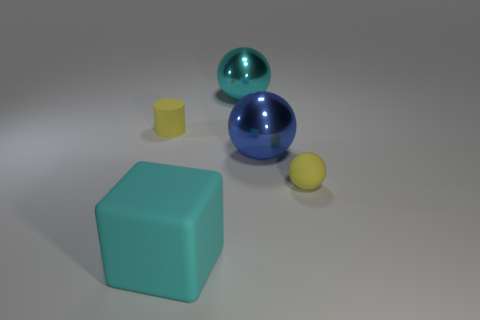What is the big blue object made of?
Give a very brief answer. Metal. The large matte cube in front of the yellow matte object that is behind the tiny yellow rubber object that is on the right side of the yellow rubber cylinder is what color?
Your answer should be very brief. Cyan. There is a yellow object that is the same shape as the big blue object; what is its material?
Make the answer very short. Rubber. How many balls are the same size as the cyan cube?
Your answer should be compact. 2. What number of cyan cubes are there?
Provide a short and direct response. 1. Is the tiny yellow sphere made of the same material as the thing left of the cube?
Your answer should be compact. Yes. What number of yellow things are cylinders or big shiny spheres?
Your response must be concise. 1. There is a cylinder that is made of the same material as the tiny sphere; what is its size?
Offer a terse response. Small. How many tiny yellow objects have the same shape as the big blue object?
Your response must be concise. 1. Is the number of objects that are on the left side of the big rubber thing greater than the number of blue spheres behind the rubber cylinder?
Give a very brief answer. Yes. 